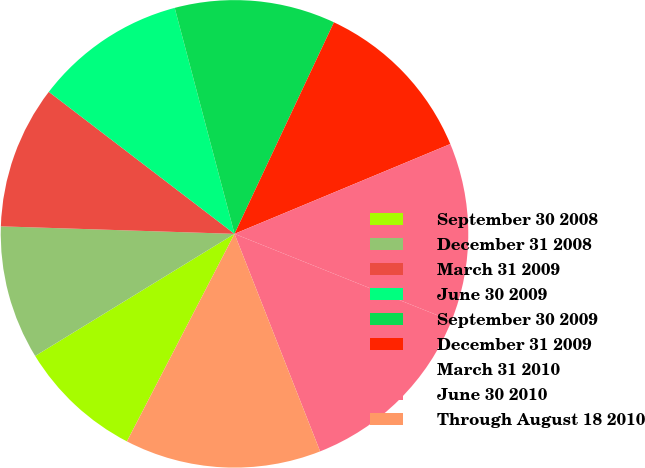Convert chart. <chart><loc_0><loc_0><loc_500><loc_500><pie_chart><fcel>September 30 2008<fcel>December 31 2008<fcel>March 31 2009<fcel>June 30 2009<fcel>September 30 2009<fcel>December 31 2009<fcel>March 31 2010<fcel>June 30 2010<fcel>Through August 18 2010<nl><fcel>8.64%<fcel>9.26%<fcel>9.88%<fcel>10.49%<fcel>11.11%<fcel>11.73%<fcel>12.35%<fcel>12.96%<fcel>13.58%<nl></chart> 